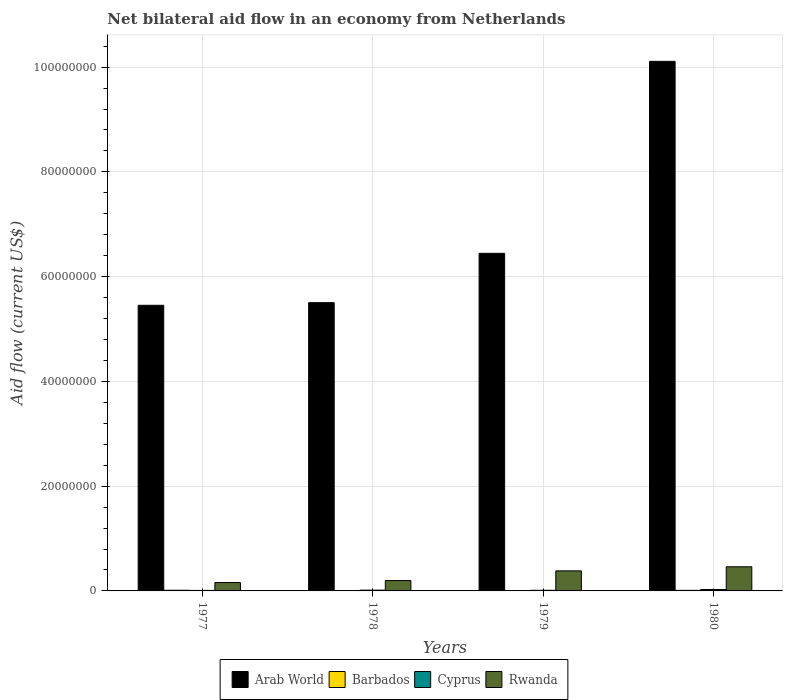How many groups of bars are there?
Give a very brief answer. 4. Are the number of bars per tick equal to the number of legend labels?
Ensure brevity in your answer.  Yes. Are the number of bars on each tick of the X-axis equal?
Your answer should be compact. Yes. What is the label of the 2nd group of bars from the left?
Ensure brevity in your answer.  1978. In how many cases, is the number of bars for a given year not equal to the number of legend labels?
Offer a terse response. 0. Across all years, what is the maximum net bilateral aid flow in Cyprus?
Ensure brevity in your answer.  2.70e+05. Across all years, what is the minimum net bilateral aid flow in Cyprus?
Offer a terse response. 1.00e+05. In which year was the net bilateral aid flow in Rwanda maximum?
Your response must be concise. 1980. What is the total net bilateral aid flow in Arab World in the graph?
Your answer should be compact. 2.75e+08. What is the difference between the net bilateral aid flow in Barbados in 1977 and that in 1980?
Provide a short and direct response. 2.00e+04. What is the difference between the net bilateral aid flow in Arab World in 1977 and the net bilateral aid flow in Rwanda in 1980?
Your response must be concise. 4.99e+07. What is the average net bilateral aid flow in Rwanda per year?
Offer a terse response. 3.00e+06. In the year 1980, what is the difference between the net bilateral aid flow in Cyprus and net bilateral aid flow in Rwanda?
Your answer should be compact. -4.34e+06. What is the ratio of the net bilateral aid flow in Cyprus in 1978 to that in 1980?
Provide a short and direct response. 0.56. Is it the case that in every year, the sum of the net bilateral aid flow in Cyprus and net bilateral aid flow in Rwanda is greater than the sum of net bilateral aid flow in Barbados and net bilateral aid flow in Arab World?
Offer a terse response. No. What does the 4th bar from the left in 1980 represents?
Make the answer very short. Rwanda. What does the 2nd bar from the right in 1980 represents?
Ensure brevity in your answer.  Cyprus. Are all the bars in the graph horizontal?
Ensure brevity in your answer.  No. Are the values on the major ticks of Y-axis written in scientific E-notation?
Make the answer very short. No. Does the graph contain grids?
Your answer should be very brief. Yes. How many legend labels are there?
Keep it short and to the point. 4. How are the legend labels stacked?
Your response must be concise. Horizontal. What is the title of the graph?
Your response must be concise. Net bilateral aid flow in an economy from Netherlands. What is the label or title of the Y-axis?
Your response must be concise. Aid flow (current US$). What is the Aid flow (current US$) in Arab World in 1977?
Make the answer very short. 5.45e+07. What is the Aid flow (current US$) of Rwanda in 1977?
Your response must be concise. 1.60e+06. What is the Aid flow (current US$) of Arab World in 1978?
Your answer should be very brief. 5.50e+07. What is the Aid flow (current US$) in Cyprus in 1978?
Keep it short and to the point. 1.50e+05. What is the Aid flow (current US$) in Rwanda in 1978?
Your response must be concise. 1.98e+06. What is the Aid flow (current US$) in Arab World in 1979?
Your response must be concise. 6.44e+07. What is the Aid flow (current US$) in Cyprus in 1979?
Make the answer very short. 1.20e+05. What is the Aid flow (current US$) of Rwanda in 1979?
Offer a very short reply. 3.83e+06. What is the Aid flow (current US$) of Arab World in 1980?
Offer a very short reply. 1.01e+08. What is the Aid flow (current US$) in Barbados in 1980?
Keep it short and to the point. 1.10e+05. What is the Aid flow (current US$) of Cyprus in 1980?
Your answer should be compact. 2.70e+05. What is the Aid flow (current US$) in Rwanda in 1980?
Provide a short and direct response. 4.61e+06. Across all years, what is the maximum Aid flow (current US$) in Arab World?
Provide a short and direct response. 1.01e+08. Across all years, what is the maximum Aid flow (current US$) in Barbados?
Your answer should be compact. 1.30e+05. Across all years, what is the maximum Aid flow (current US$) in Cyprus?
Your answer should be compact. 2.70e+05. Across all years, what is the maximum Aid flow (current US$) in Rwanda?
Make the answer very short. 4.61e+06. Across all years, what is the minimum Aid flow (current US$) of Arab World?
Ensure brevity in your answer.  5.45e+07. Across all years, what is the minimum Aid flow (current US$) of Cyprus?
Provide a succinct answer. 1.00e+05. Across all years, what is the minimum Aid flow (current US$) of Rwanda?
Provide a short and direct response. 1.60e+06. What is the total Aid flow (current US$) in Arab World in the graph?
Keep it short and to the point. 2.75e+08. What is the total Aid flow (current US$) of Cyprus in the graph?
Your answer should be very brief. 6.40e+05. What is the total Aid flow (current US$) of Rwanda in the graph?
Provide a succinct answer. 1.20e+07. What is the difference between the Aid flow (current US$) in Arab World in 1977 and that in 1978?
Your answer should be compact. -5.00e+05. What is the difference between the Aid flow (current US$) in Rwanda in 1977 and that in 1978?
Provide a succinct answer. -3.80e+05. What is the difference between the Aid flow (current US$) of Arab World in 1977 and that in 1979?
Keep it short and to the point. -9.92e+06. What is the difference between the Aid flow (current US$) in Barbados in 1977 and that in 1979?
Offer a terse response. 9.00e+04. What is the difference between the Aid flow (current US$) of Rwanda in 1977 and that in 1979?
Ensure brevity in your answer.  -2.23e+06. What is the difference between the Aid flow (current US$) in Arab World in 1977 and that in 1980?
Give a very brief answer. -4.66e+07. What is the difference between the Aid flow (current US$) of Barbados in 1977 and that in 1980?
Your answer should be very brief. 2.00e+04. What is the difference between the Aid flow (current US$) of Rwanda in 1977 and that in 1980?
Your response must be concise. -3.01e+06. What is the difference between the Aid flow (current US$) of Arab World in 1978 and that in 1979?
Provide a short and direct response. -9.42e+06. What is the difference between the Aid flow (current US$) in Barbados in 1978 and that in 1979?
Your answer should be very brief. 3.00e+04. What is the difference between the Aid flow (current US$) in Cyprus in 1978 and that in 1979?
Offer a very short reply. 3.00e+04. What is the difference between the Aid flow (current US$) in Rwanda in 1978 and that in 1979?
Your answer should be very brief. -1.85e+06. What is the difference between the Aid flow (current US$) of Arab World in 1978 and that in 1980?
Offer a very short reply. -4.61e+07. What is the difference between the Aid flow (current US$) of Barbados in 1978 and that in 1980?
Keep it short and to the point. -4.00e+04. What is the difference between the Aid flow (current US$) of Cyprus in 1978 and that in 1980?
Ensure brevity in your answer.  -1.20e+05. What is the difference between the Aid flow (current US$) in Rwanda in 1978 and that in 1980?
Offer a terse response. -2.63e+06. What is the difference between the Aid flow (current US$) of Arab World in 1979 and that in 1980?
Your answer should be compact. -3.66e+07. What is the difference between the Aid flow (current US$) in Cyprus in 1979 and that in 1980?
Provide a succinct answer. -1.50e+05. What is the difference between the Aid flow (current US$) in Rwanda in 1979 and that in 1980?
Offer a very short reply. -7.80e+05. What is the difference between the Aid flow (current US$) of Arab World in 1977 and the Aid flow (current US$) of Barbados in 1978?
Your response must be concise. 5.45e+07. What is the difference between the Aid flow (current US$) in Arab World in 1977 and the Aid flow (current US$) in Cyprus in 1978?
Provide a short and direct response. 5.44e+07. What is the difference between the Aid flow (current US$) in Arab World in 1977 and the Aid flow (current US$) in Rwanda in 1978?
Give a very brief answer. 5.26e+07. What is the difference between the Aid flow (current US$) in Barbados in 1977 and the Aid flow (current US$) in Rwanda in 1978?
Offer a terse response. -1.85e+06. What is the difference between the Aid flow (current US$) in Cyprus in 1977 and the Aid flow (current US$) in Rwanda in 1978?
Offer a terse response. -1.88e+06. What is the difference between the Aid flow (current US$) in Arab World in 1977 and the Aid flow (current US$) in Barbados in 1979?
Ensure brevity in your answer.  5.45e+07. What is the difference between the Aid flow (current US$) of Arab World in 1977 and the Aid flow (current US$) of Cyprus in 1979?
Give a very brief answer. 5.44e+07. What is the difference between the Aid flow (current US$) in Arab World in 1977 and the Aid flow (current US$) in Rwanda in 1979?
Give a very brief answer. 5.07e+07. What is the difference between the Aid flow (current US$) in Barbados in 1977 and the Aid flow (current US$) in Cyprus in 1979?
Keep it short and to the point. 10000. What is the difference between the Aid flow (current US$) of Barbados in 1977 and the Aid flow (current US$) of Rwanda in 1979?
Keep it short and to the point. -3.70e+06. What is the difference between the Aid flow (current US$) of Cyprus in 1977 and the Aid flow (current US$) of Rwanda in 1979?
Your answer should be very brief. -3.73e+06. What is the difference between the Aid flow (current US$) in Arab World in 1977 and the Aid flow (current US$) in Barbados in 1980?
Ensure brevity in your answer.  5.44e+07. What is the difference between the Aid flow (current US$) of Arab World in 1977 and the Aid flow (current US$) of Cyprus in 1980?
Offer a very short reply. 5.43e+07. What is the difference between the Aid flow (current US$) in Arab World in 1977 and the Aid flow (current US$) in Rwanda in 1980?
Offer a very short reply. 4.99e+07. What is the difference between the Aid flow (current US$) in Barbados in 1977 and the Aid flow (current US$) in Rwanda in 1980?
Offer a very short reply. -4.48e+06. What is the difference between the Aid flow (current US$) of Cyprus in 1977 and the Aid flow (current US$) of Rwanda in 1980?
Give a very brief answer. -4.51e+06. What is the difference between the Aid flow (current US$) in Arab World in 1978 and the Aid flow (current US$) in Barbados in 1979?
Provide a short and direct response. 5.50e+07. What is the difference between the Aid flow (current US$) in Arab World in 1978 and the Aid flow (current US$) in Cyprus in 1979?
Your answer should be very brief. 5.49e+07. What is the difference between the Aid flow (current US$) of Arab World in 1978 and the Aid flow (current US$) of Rwanda in 1979?
Your answer should be very brief. 5.12e+07. What is the difference between the Aid flow (current US$) in Barbados in 1978 and the Aid flow (current US$) in Cyprus in 1979?
Provide a succinct answer. -5.00e+04. What is the difference between the Aid flow (current US$) of Barbados in 1978 and the Aid flow (current US$) of Rwanda in 1979?
Your answer should be very brief. -3.76e+06. What is the difference between the Aid flow (current US$) of Cyprus in 1978 and the Aid flow (current US$) of Rwanda in 1979?
Keep it short and to the point. -3.68e+06. What is the difference between the Aid flow (current US$) of Arab World in 1978 and the Aid flow (current US$) of Barbados in 1980?
Offer a terse response. 5.49e+07. What is the difference between the Aid flow (current US$) of Arab World in 1978 and the Aid flow (current US$) of Cyprus in 1980?
Offer a very short reply. 5.48e+07. What is the difference between the Aid flow (current US$) of Arab World in 1978 and the Aid flow (current US$) of Rwanda in 1980?
Provide a short and direct response. 5.04e+07. What is the difference between the Aid flow (current US$) of Barbados in 1978 and the Aid flow (current US$) of Cyprus in 1980?
Provide a succinct answer. -2.00e+05. What is the difference between the Aid flow (current US$) of Barbados in 1978 and the Aid flow (current US$) of Rwanda in 1980?
Your answer should be very brief. -4.54e+06. What is the difference between the Aid flow (current US$) of Cyprus in 1978 and the Aid flow (current US$) of Rwanda in 1980?
Your answer should be compact. -4.46e+06. What is the difference between the Aid flow (current US$) of Arab World in 1979 and the Aid flow (current US$) of Barbados in 1980?
Your response must be concise. 6.43e+07. What is the difference between the Aid flow (current US$) of Arab World in 1979 and the Aid flow (current US$) of Cyprus in 1980?
Make the answer very short. 6.42e+07. What is the difference between the Aid flow (current US$) of Arab World in 1979 and the Aid flow (current US$) of Rwanda in 1980?
Keep it short and to the point. 5.98e+07. What is the difference between the Aid flow (current US$) of Barbados in 1979 and the Aid flow (current US$) of Rwanda in 1980?
Offer a very short reply. -4.57e+06. What is the difference between the Aid flow (current US$) in Cyprus in 1979 and the Aid flow (current US$) in Rwanda in 1980?
Keep it short and to the point. -4.49e+06. What is the average Aid flow (current US$) of Arab World per year?
Offer a very short reply. 6.88e+07. What is the average Aid flow (current US$) in Barbados per year?
Provide a succinct answer. 8.75e+04. What is the average Aid flow (current US$) of Rwanda per year?
Your answer should be very brief. 3.00e+06. In the year 1977, what is the difference between the Aid flow (current US$) of Arab World and Aid flow (current US$) of Barbados?
Provide a short and direct response. 5.44e+07. In the year 1977, what is the difference between the Aid flow (current US$) in Arab World and Aid flow (current US$) in Cyprus?
Your answer should be compact. 5.44e+07. In the year 1977, what is the difference between the Aid flow (current US$) in Arab World and Aid flow (current US$) in Rwanda?
Offer a very short reply. 5.29e+07. In the year 1977, what is the difference between the Aid flow (current US$) of Barbados and Aid flow (current US$) of Cyprus?
Provide a succinct answer. 3.00e+04. In the year 1977, what is the difference between the Aid flow (current US$) in Barbados and Aid flow (current US$) in Rwanda?
Ensure brevity in your answer.  -1.47e+06. In the year 1977, what is the difference between the Aid flow (current US$) in Cyprus and Aid flow (current US$) in Rwanda?
Provide a succinct answer. -1.50e+06. In the year 1978, what is the difference between the Aid flow (current US$) of Arab World and Aid flow (current US$) of Barbados?
Your response must be concise. 5.50e+07. In the year 1978, what is the difference between the Aid flow (current US$) in Arab World and Aid flow (current US$) in Cyprus?
Ensure brevity in your answer.  5.49e+07. In the year 1978, what is the difference between the Aid flow (current US$) in Arab World and Aid flow (current US$) in Rwanda?
Your response must be concise. 5.30e+07. In the year 1978, what is the difference between the Aid flow (current US$) of Barbados and Aid flow (current US$) of Rwanda?
Provide a succinct answer. -1.91e+06. In the year 1978, what is the difference between the Aid flow (current US$) of Cyprus and Aid flow (current US$) of Rwanda?
Offer a terse response. -1.83e+06. In the year 1979, what is the difference between the Aid flow (current US$) in Arab World and Aid flow (current US$) in Barbados?
Ensure brevity in your answer.  6.44e+07. In the year 1979, what is the difference between the Aid flow (current US$) of Arab World and Aid flow (current US$) of Cyprus?
Keep it short and to the point. 6.43e+07. In the year 1979, what is the difference between the Aid flow (current US$) in Arab World and Aid flow (current US$) in Rwanda?
Provide a succinct answer. 6.06e+07. In the year 1979, what is the difference between the Aid flow (current US$) of Barbados and Aid flow (current US$) of Cyprus?
Offer a terse response. -8.00e+04. In the year 1979, what is the difference between the Aid flow (current US$) in Barbados and Aid flow (current US$) in Rwanda?
Offer a very short reply. -3.79e+06. In the year 1979, what is the difference between the Aid flow (current US$) in Cyprus and Aid flow (current US$) in Rwanda?
Your answer should be compact. -3.71e+06. In the year 1980, what is the difference between the Aid flow (current US$) of Arab World and Aid flow (current US$) of Barbados?
Your answer should be compact. 1.01e+08. In the year 1980, what is the difference between the Aid flow (current US$) in Arab World and Aid flow (current US$) in Cyprus?
Ensure brevity in your answer.  1.01e+08. In the year 1980, what is the difference between the Aid flow (current US$) of Arab World and Aid flow (current US$) of Rwanda?
Make the answer very short. 9.65e+07. In the year 1980, what is the difference between the Aid flow (current US$) of Barbados and Aid flow (current US$) of Cyprus?
Keep it short and to the point. -1.60e+05. In the year 1980, what is the difference between the Aid flow (current US$) of Barbados and Aid flow (current US$) of Rwanda?
Your answer should be compact. -4.50e+06. In the year 1980, what is the difference between the Aid flow (current US$) of Cyprus and Aid flow (current US$) of Rwanda?
Provide a short and direct response. -4.34e+06. What is the ratio of the Aid flow (current US$) of Arab World in 1977 to that in 1978?
Ensure brevity in your answer.  0.99. What is the ratio of the Aid flow (current US$) of Barbados in 1977 to that in 1978?
Provide a short and direct response. 1.86. What is the ratio of the Aid flow (current US$) of Rwanda in 1977 to that in 1978?
Keep it short and to the point. 0.81. What is the ratio of the Aid flow (current US$) in Arab World in 1977 to that in 1979?
Offer a very short reply. 0.85. What is the ratio of the Aid flow (current US$) of Rwanda in 1977 to that in 1979?
Keep it short and to the point. 0.42. What is the ratio of the Aid flow (current US$) of Arab World in 1977 to that in 1980?
Offer a terse response. 0.54. What is the ratio of the Aid flow (current US$) of Barbados in 1977 to that in 1980?
Provide a succinct answer. 1.18. What is the ratio of the Aid flow (current US$) of Cyprus in 1977 to that in 1980?
Offer a very short reply. 0.37. What is the ratio of the Aid flow (current US$) in Rwanda in 1977 to that in 1980?
Offer a terse response. 0.35. What is the ratio of the Aid flow (current US$) of Arab World in 1978 to that in 1979?
Ensure brevity in your answer.  0.85. What is the ratio of the Aid flow (current US$) of Barbados in 1978 to that in 1979?
Your response must be concise. 1.75. What is the ratio of the Aid flow (current US$) of Rwanda in 1978 to that in 1979?
Ensure brevity in your answer.  0.52. What is the ratio of the Aid flow (current US$) of Arab World in 1978 to that in 1980?
Your response must be concise. 0.54. What is the ratio of the Aid flow (current US$) in Barbados in 1978 to that in 1980?
Keep it short and to the point. 0.64. What is the ratio of the Aid flow (current US$) of Cyprus in 1978 to that in 1980?
Ensure brevity in your answer.  0.56. What is the ratio of the Aid flow (current US$) in Rwanda in 1978 to that in 1980?
Offer a very short reply. 0.43. What is the ratio of the Aid flow (current US$) of Arab World in 1979 to that in 1980?
Offer a terse response. 0.64. What is the ratio of the Aid flow (current US$) of Barbados in 1979 to that in 1980?
Offer a terse response. 0.36. What is the ratio of the Aid flow (current US$) of Cyprus in 1979 to that in 1980?
Offer a very short reply. 0.44. What is the ratio of the Aid flow (current US$) in Rwanda in 1979 to that in 1980?
Keep it short and to the point. 0.83. What is the difference between the highest and the second highest Aid flow (current US$) in Arab World?
Provide a succinct answer. 3.66e+07. What is the difference between the highest and the second highest Aid flow (current US$) in Barbados?
Your response must be concise. 2.00e+04. What is the difference between the highest and the second highest Aid flow (current US$) of Rwanda?
Ensure brevity in your answer.  7.80e+05. What is the difference between the highest and the lowest Aid flow (current US$) of Arab World?
Provide a succinct answer. 4.66e+07. What is the difference between the highest and the lowest Aid flow (current US$) in Rwanda?
Offer a terse response. 3.01e+06. 